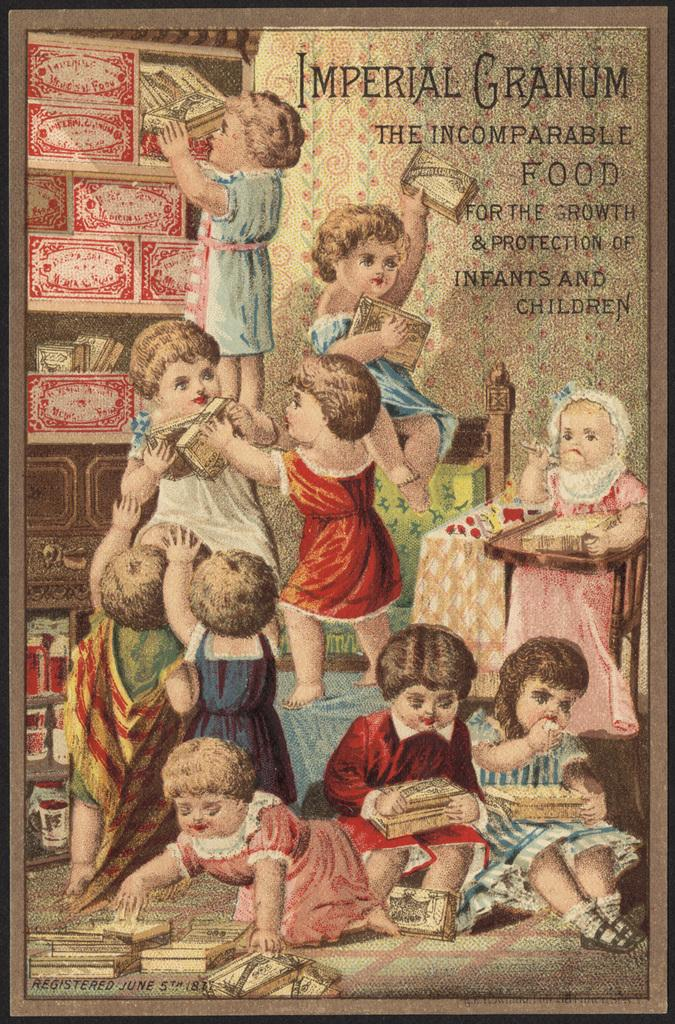What is the main subject of the poster in the image? The poster contains images of children and objects. What else can be found on the poster besides images? There is text on the poster. What type of ship is sailing in the background of the poster? There is no ship visible in the image; the poster contains images of children and objects, along with text. 